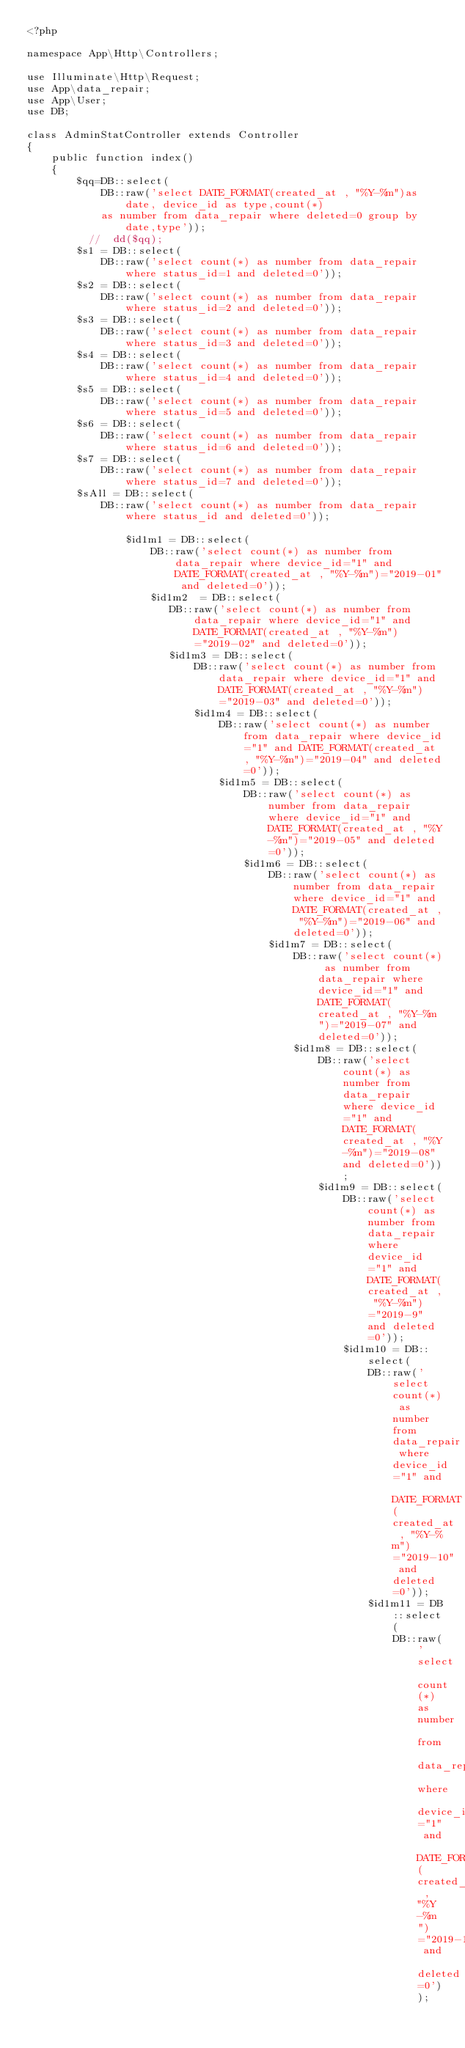<code> <loc_0><loc_0><loc_500><loc_500><_PHP_><?php

namespace App\Http\Controllers;

use Illuminate\Http\Request;
use App\data_repair;
use App\User;
use DB;

class AdminStatController extends Controller
{
    public function index()
    {
        $qq=DB::select( 
            DB::raw('select DATE_FORMAT(created_at , "%Y-%m")as date, device_id as type,count(*) 
            as number from data_repair where deleted=0 group by date,type'));
          //  dd($qq);
        $s1 = DB::select( 
            DB::raw('select count(*) as number from data_repair where status_id=1 and deleted=0'));
        $s2 = DB::select( 
            DB::raw('select count(*) as number from data_repair where status_id=2 and deleted=0'));
        $s3 = DB::select( 
            DB::raw('select count(*) as number from data_repair where status_id=3 and deleted=0'));
        $s4 = DB::select( 
            DB::raw('select count(*) as number from data_repair where status_id=4 and deleted=0'));
        $s5 = DB::select( 
            DB::raw('select count(*) as number from data_repair where status_id=5 and deleted=0'));
        $s6 = DB::select( 
            DB::raw('select count(*) as number from data_repair where status_id=6 and deleted=0'));
        $s7 = DB::select( 
            DB::raw('select count(*) as number from data_repair where status_id=7 and deleted=0'));
        $sAll = DB::select( 
            DB::raw('select count(*) as number from data_repair where status_id and deleted=0'));
 
                $id1m1 = DB::select( 
                    DB::raw('select count(*) as number from data_repair where device_id="1" and DATE_FORMAT(created_at , "%Y-%m")="2019-01" and deleted=0'));
                    $id1m2  = DB::select( 
                       DB::raw('select count(*) as number from data_repair where device_id="1" and DATE_FORMAT(created_at , "%Y-%m")="2019-02" and deleted=0'));               
                       $id1m3 = DB::select( 
                           DB::raw('select count(*) as number from data_repair where device_id="1" and DATE_FORMAT(created_at , "%Y-%m")="2019-03" and deleted=0'));
                           $id1m4 = DB::select( 
                               DB::raw('select count(*) as number from data_repair where device_id="1" and DATE_FORMAT(created_at , "%Y-%m")="2019-04" and deleted=0'));
                               $id1m5 = DB::select( 
                                   DB::raw('select count(*) as number from data_repair where device_id="1" and DATE_FORMAT(created_at , "%Y-%m")="2019-05" and deleted=0'));
                                   $id1m6 = DB::select( 
                                       DB::raw('select count(*) as number from data_repair where device_id="1" and DATE_FORMAT(created_at , "%Y-%m")="2019-06" and deleted=0'));
                                       $id1m7 = DB::select( 
                                           DB::raw('select count(*) as number from data_repair where device_id="1" and DATE_FORMAT(created_at , "%Y-%m")="2019-07" and deleted=0'));
                                           $id1m8 = DB::select( 
                                               DB::raw('select count(*) as number from data_repair where device_id="1" and DATE_FORMAT(created_at , "%Y-%m")="2019-08" and deleted=0'));
                                               $id1m9 = DB::select( 
                                                   DB::raw('select count(*) as number from data_repair where device_id="1" and DATE_FORMAT(created_at , "%Y-%m")="2019-9" and deleted=0'));
                                                   $id1m10 = DB::select( 
                                                       DB::raw('select count(*) as number from data_repair where device_id="1" and DATE_FORMAT(created_at , "%Y-%m")="2019-10" and deleted=0'));
                                                       $id1m11 = DB::select( 
                                                           DB::raw('select count(*) as number from data_repair where device_id="1" and DATE_FORMAT(created_at , "%Y-%m")="2019-11" and deleted=0'));</code> 